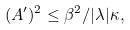<formula> <loc_0><loc_0><loc_500><loc_500>( A ^ { \prime } ) ^ { 2 } \leq \beta ^ { 2 } / | \lambda | \kappa ,</formula> 